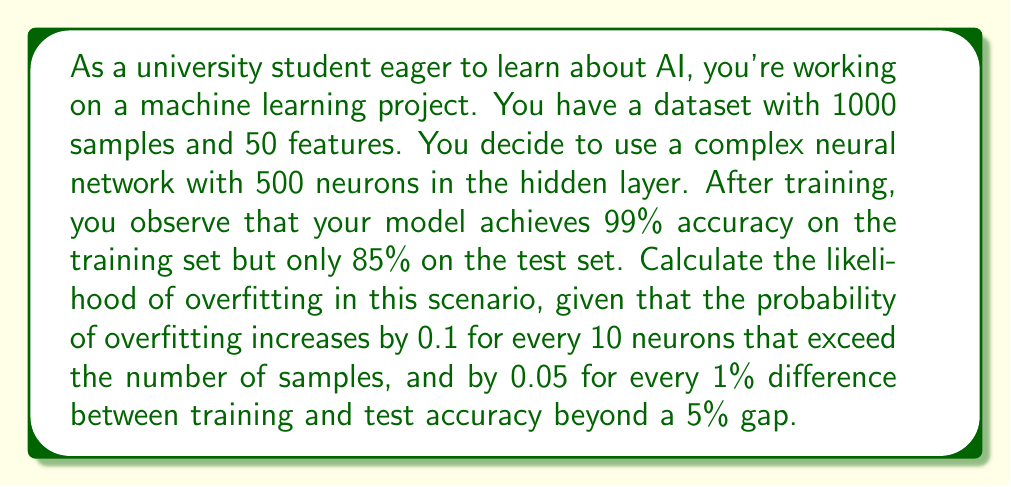Provide a solution to this math problem. To determine the likelihood of overfitting, we need to consider two factors:

1. The complexity of the model relative to the dataset size
2. The difference between training and test accuracy

Let's break down the problem step-by-step:

1. Model complexity:
   - Number of samples: 1000
   - Number of neurons in the hidden layer: 500
   - Excess neurons = 500 - 1000 = -500 (no excess)
   - Since there are no excess neurons, this factor doesn't contribute to overfitting probability.

2. Accuracy difference:
   - Training accuracy: 99%
   - Test accuracy: 85%
   - Difference: 99% - 85% = 14%
   - Excess difference beyond 5%: 14% - 5% = 9%

Now, let's calculate the overfitting probability:

$$P(\text{overfitting}) = 0.05 \times \frac{\text{excess accuracy difference}}{1\%}$$

$$P(\text{overfitting}) = 0.05 \times \frac{9}{1} = 0.45$$

Therefore, the likelihood of overfitting in this scenario is 0.45 or 45%.
Answer: The likelihood of overfitting in this scenario is 0.45 or 45%. 